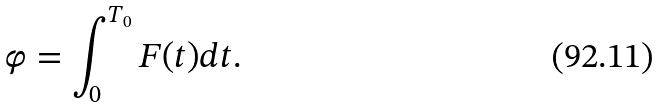Convert formula to latex. <formula><loc_0><loc_0><loc_500><loc_500>\varphi = \int _ { 0 } ^ { T _ { 0 } } F ( t ) d t .</formula> 